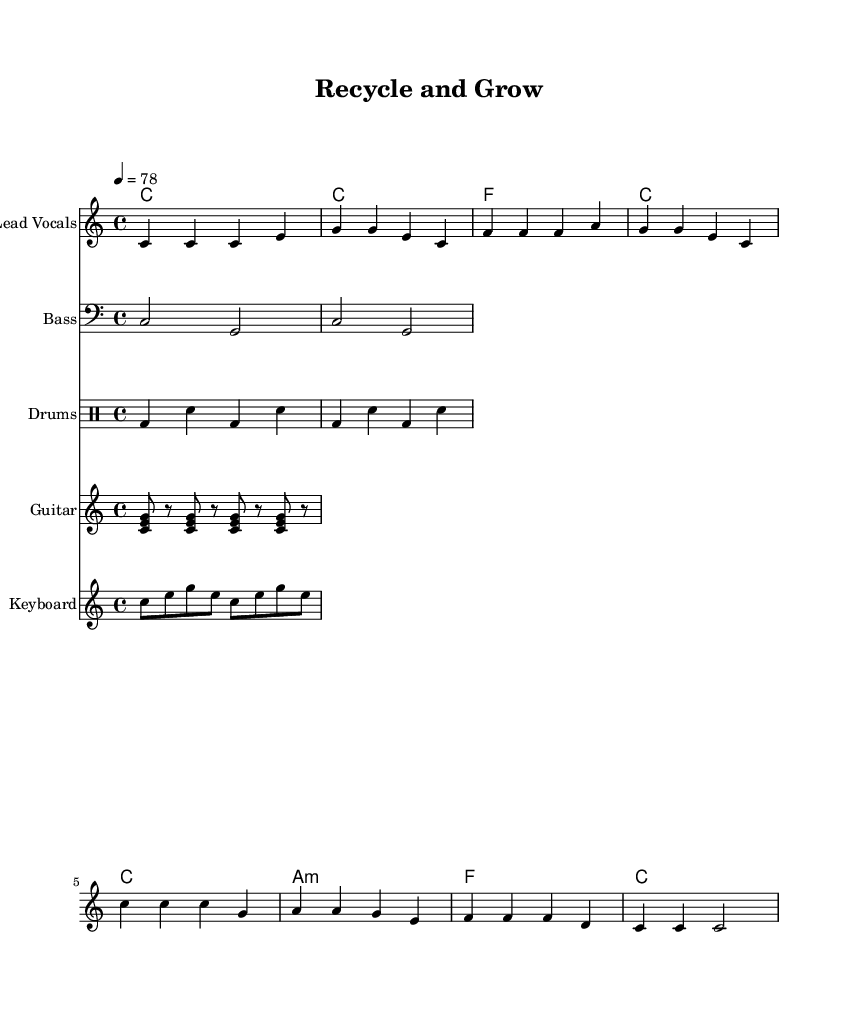What is the key signature of this music? The key signature is C major, which is indicated by the absence of any sharps or flats at the beginning of the staff.
Answer: C major What is the time signature of the piece? The time signature is indicated as 4/4 at the beginning of the staff, meaning there are four beats per measure and the quarter note receives one beat.
Answer: 4/4 What is the tempo marking of the piece? The tempo marking is stated as 4 = 78, which means there are 78 beats per minute at the quarter note.
Answer: 78 How many measures are in the melody section? By counting the measures in the melody staff, there are eight distinct measures.
Answer: 8 What is the main message portrayed in the lyrics? Analyzing the lyrics, they emphasize the importance of reducing, reusing, and recycling for environmental conservation.
Answer: Eco-friendly What is the chord that accompanies the first measure? The first measure has a chord of C major, which corresponds with the melody note C and is indicated above the staff.
Answer: C What rhythmic pattern is primarily used in the drum part? The drum part uses a steady bass drum (bd) alternating with snare (sn) notes in a simple repeating pattern, reflecting typical reggae rhythms.
Answer: Reggae rhythm 